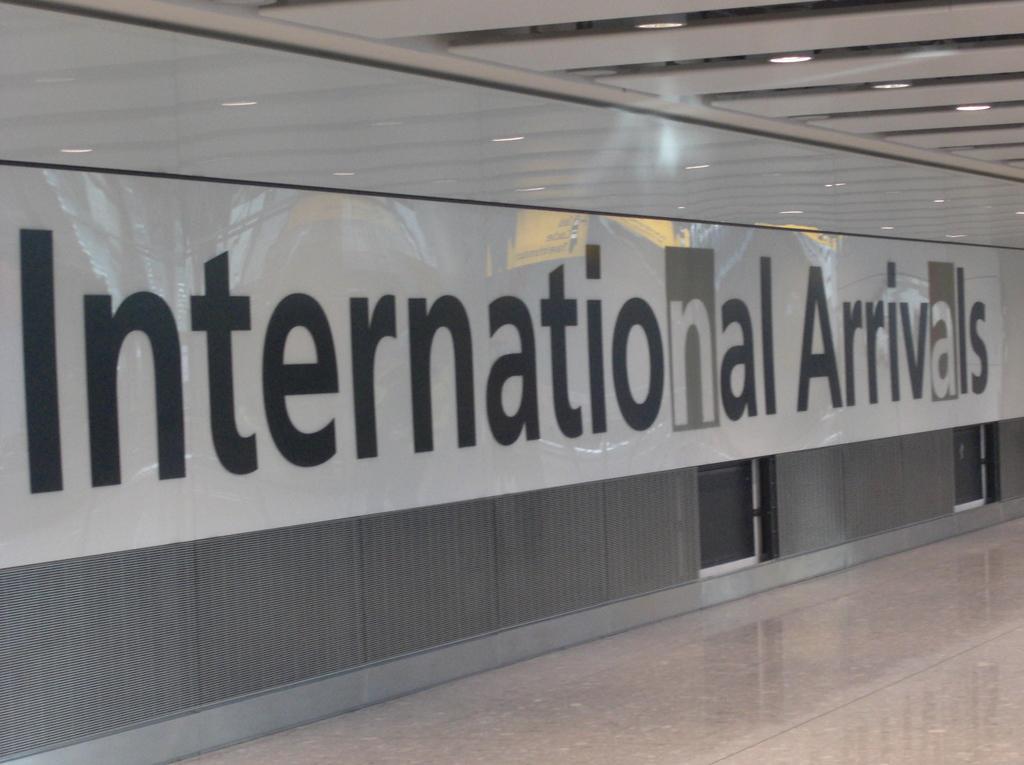Can you describe this image briefly? In this image I can see the wall. To the wall there is a name international arrivals is written on it. In-front of the wall I can see the floor. In the top there are lights and the ceiling. 